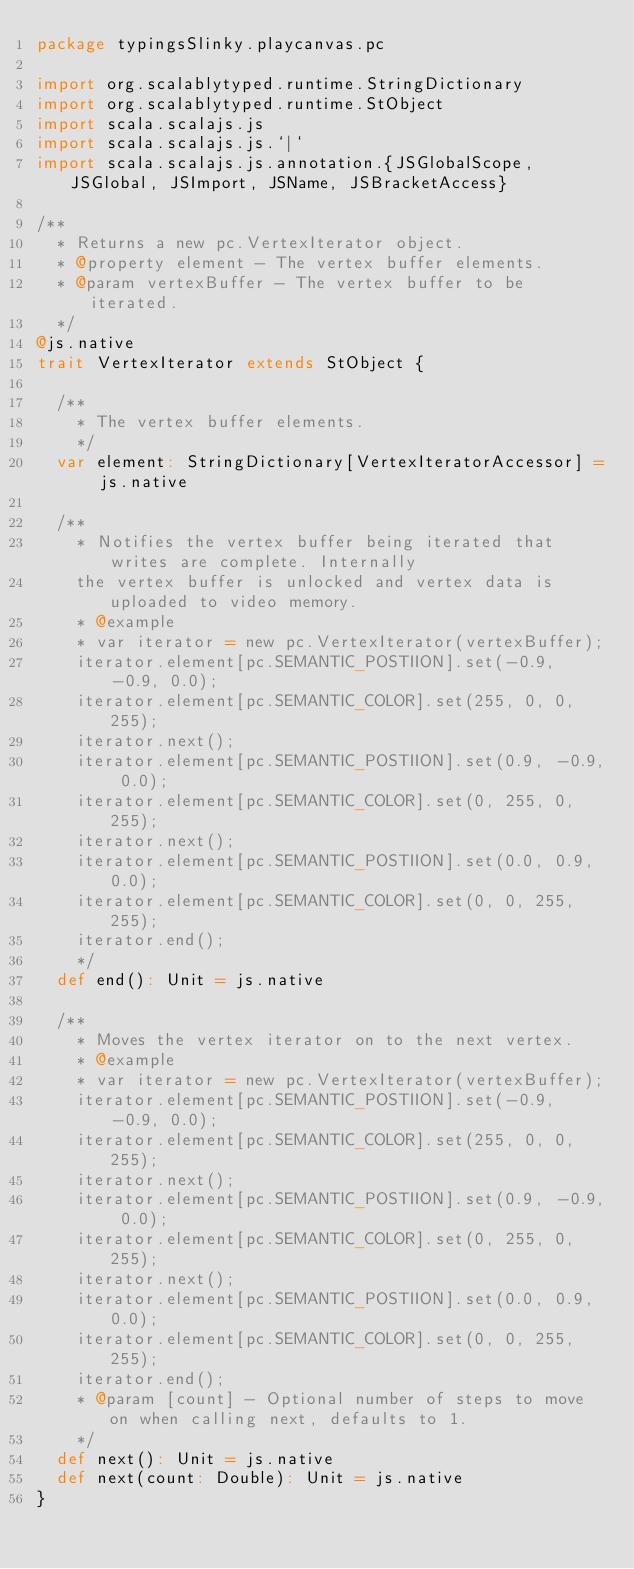<code> <loc_0><loc_0><loc_500><loc_500><_Scala_>package typingsSlinky.playcanvas.pc

import org.scalablytyped.runtime.StringDictionary
import org.scalablytyped.runtime.StObject
import scala.scalajs.js
import scala.scalajs.js.`|`
import scala.scalajs.js.annotation.{JSGlobalScope, JSGlobal, JSImport, JSName, JSBracketAccess}

/**
  * Returns a new pc.VertexIterator object.
  * @property element - The vertex buffer elements.
  * @param vertexBuffer - The vertex buffer to be iterated.
  */
@js.native
trait VertexIterator extends StObject {
  
  /**
    * The vertex buffer elements.
    */
  var element: StringDictionary[VertexIteratorAccessor] = js.native
  
  /**
    * Notifies the vertex buffer being iterated that writes are complete. Internally
    the vertex buffer is unlocked and vertex data is uploaded to video memory.
    * @example
    * var iterator = new pc.VertexIterator(vertexBuffer);
    iterator.element[pc.SEMANTIC_POSTIION].set(-0.9, -0.9, 0.0);
    iterator.element[pc.SEMANTIC_COLOR].set(255, 0, 0, 255);
    iterator.next();
    iterator.element[pc.SEMANTIC_POSTIION].set(0.9, -0.9, 0.0);
    iterator.element[pc.SEMANTIC_COLOR].set(0, 255, 0, 255);
    iterator.next();
    iterator.element[pc.SEMANTIC_POSTIION].set(0.0, 0.9, 0.0);
    iterator.element[pc.SEMANTIC_COLOR].set(0, 0, 255, 255);
    iterator.end();
    */
  def end(): Unit = js.native
  
  /**
    * Moves the vertex iterator on to the next vertex.
    * @example
    * var iterator = new pc.VertexIterator(vertexBuffer);
    iterator.element[pc.SEMANTIC_POSTIION].set(-0.9, -0.9, 0.0);
    iterator.element[pc.SEMANTIC_COLOR].set(255, 0, 0, 255);
    iterator.next();
    iterator.element[pc.SEMANTIC_POSTIION].set(0.9, -0.9, 0.0);
    iterator.element[pc.SEMANTIC_COLOR].set(0, 255, 0, 255);
    iterator.next();
    iterator.element[pc.SEMANTIC_POSTIION].set(0.0, 0.9, 0.0);
    iterator.element[pc.SEMANTIC_COLOR].set(0, 0, 255, 255);
    iterator.end();
    * @param [count] - Optional number of steps to move on when calling next, defaults to 1.
    */
  def next(): Unit = js.native
  def next(count: Double): Unit = js.native
}
</code> 